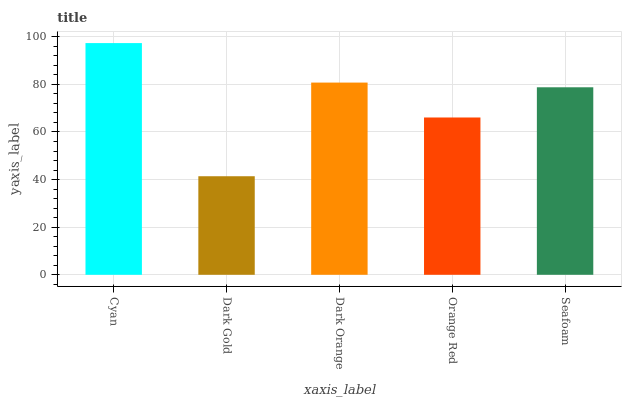Is Dark Orange the minimum?
Answer yes or no. No. Is Dark Orange the maximum?
Answer yes or no. No. Is Dark Orange greater than Dark Gold?
Answer yes or no. Yes. Is Dark Gold less than Dark Orange?
Answer yes or no. Yes. Is Dark Gold greater than Dark Orange?
Answer yes or no. No. Is Dark Orange less than Dark Gold?
Answer yes or no. No. Is Seafoam the high median?
Answer yes or no. Yes. Is Seafoam the low median?
Answer yes or no. Yes. Is Dark Orange the high median?
Answer yes or no. No. Is Dark Orange the low median?
Answer yes or no. No. 